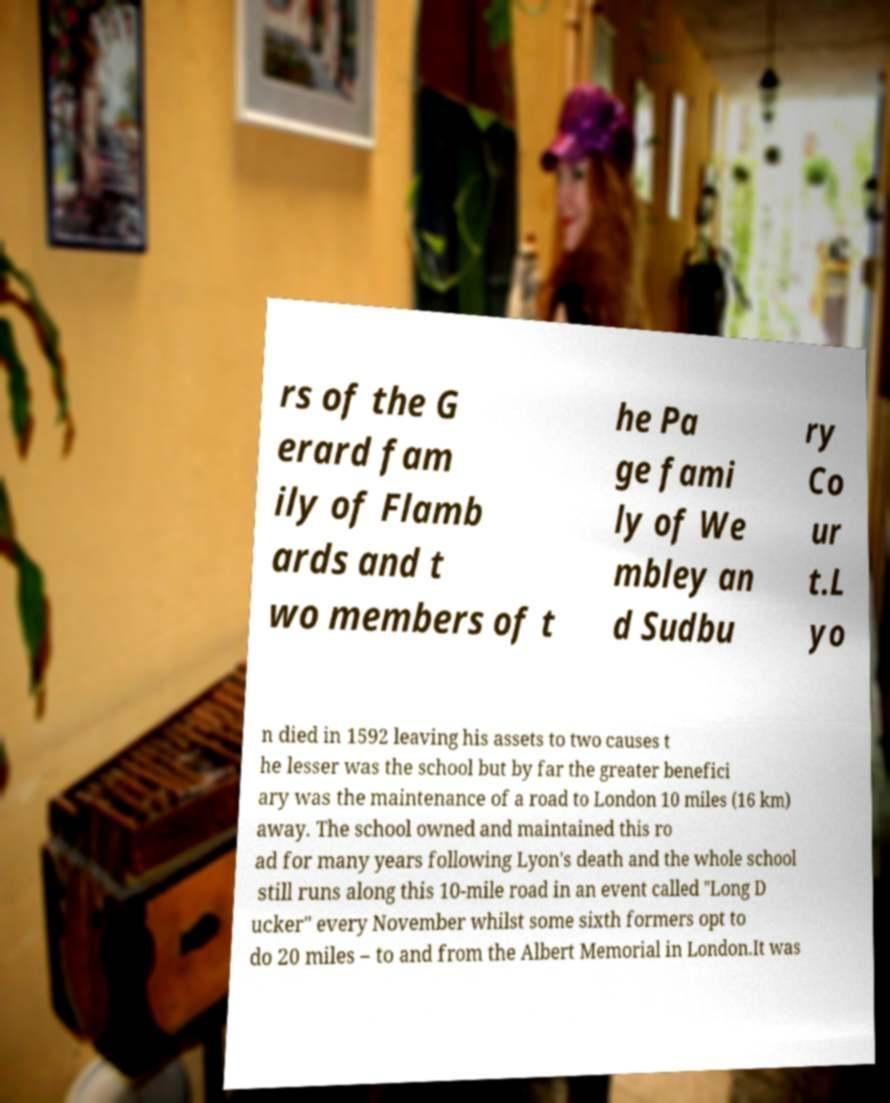What messages or text are displayed in this image? I need them in a readable, typed format. rs of the G erard fam ily of Flamb ards and t wo members of t he Pa ge fami ly of We mbley an d Sudbu ry Co ur t.L yo n died in 1592 leaving his assets to two causes t he lesser was the school but by far the greater benefici ary was the maintenance of a road to London 10 miles (16 km) away. The school owned and maintained this ro ad for many years following Lyon's death and the whole school still runs along this 10-mile road in an event called "Long D ucker" every November whilst some sixth formers opt to do 20 miles – to and from the Albert Memorial in London.It was 